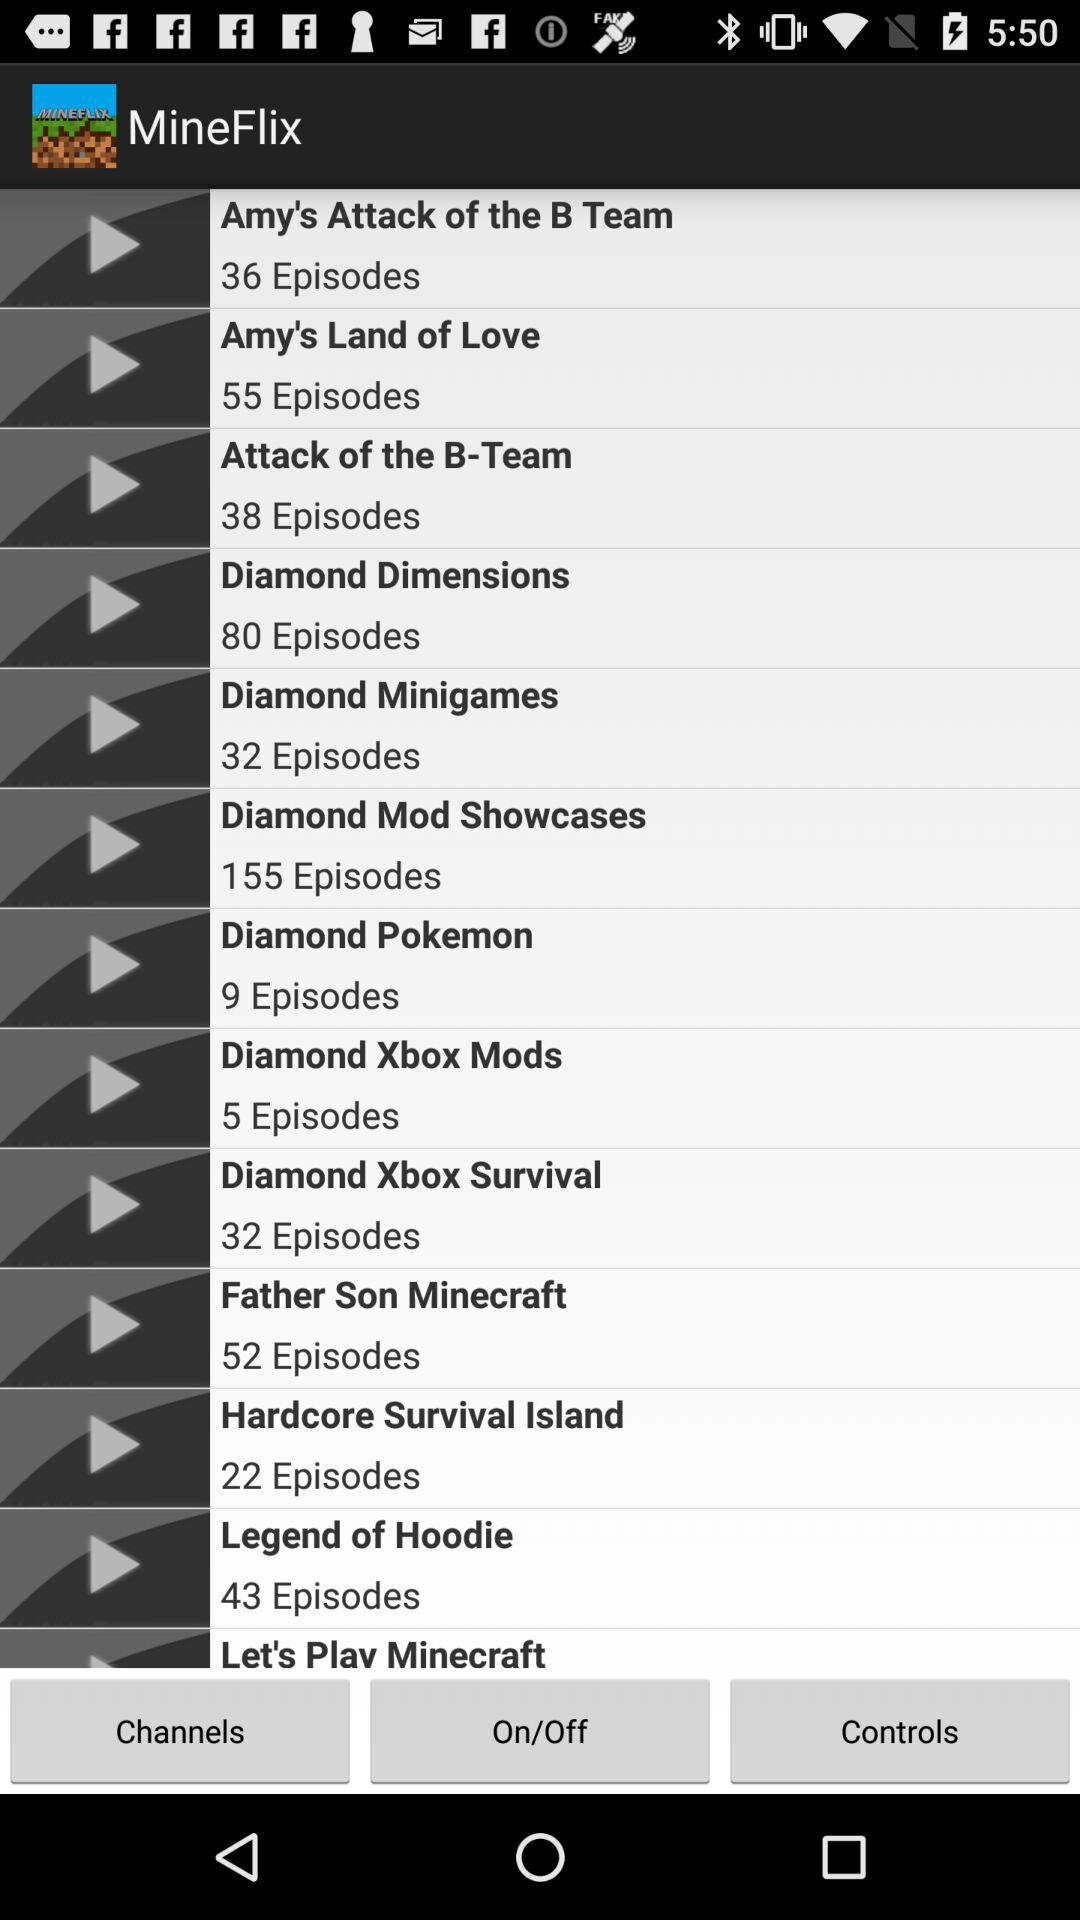How many episodes are there of Diamond Mod Showcases?
Answer the question using a single word or phrase. 155 